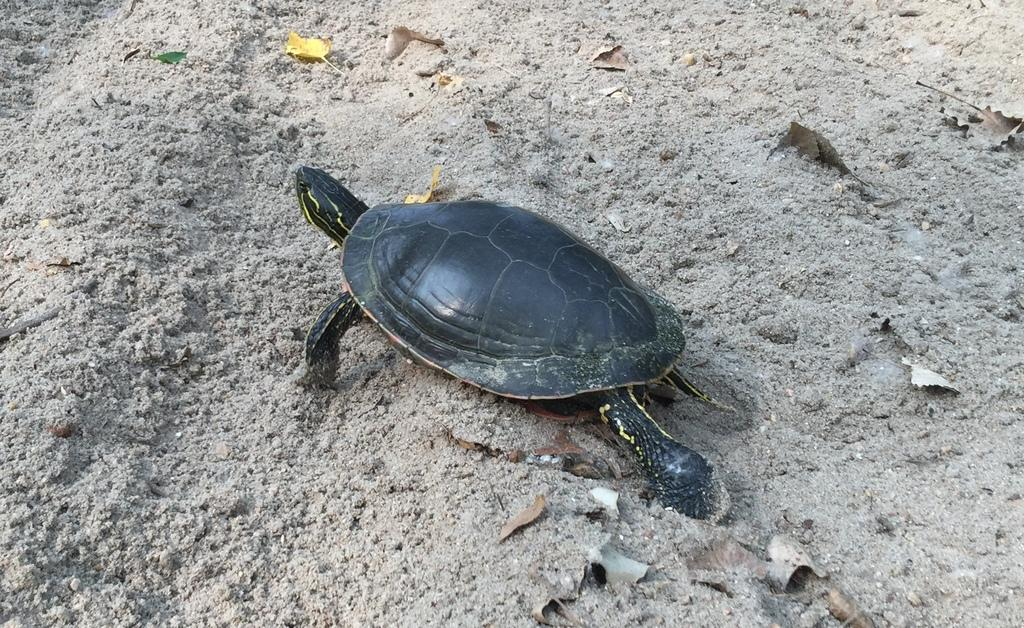What type of animal is in the image? There is a tortoise in the image. Where is the tortoise located? The tortoise is on land. What else can be seen in the image besides the tortoise? There are leaves in the image. What type of adjustment does the tortoise need to make to cross the border in the image? There is no border present in the image, and the tortoise does not need to make any adjustments to cross it. 